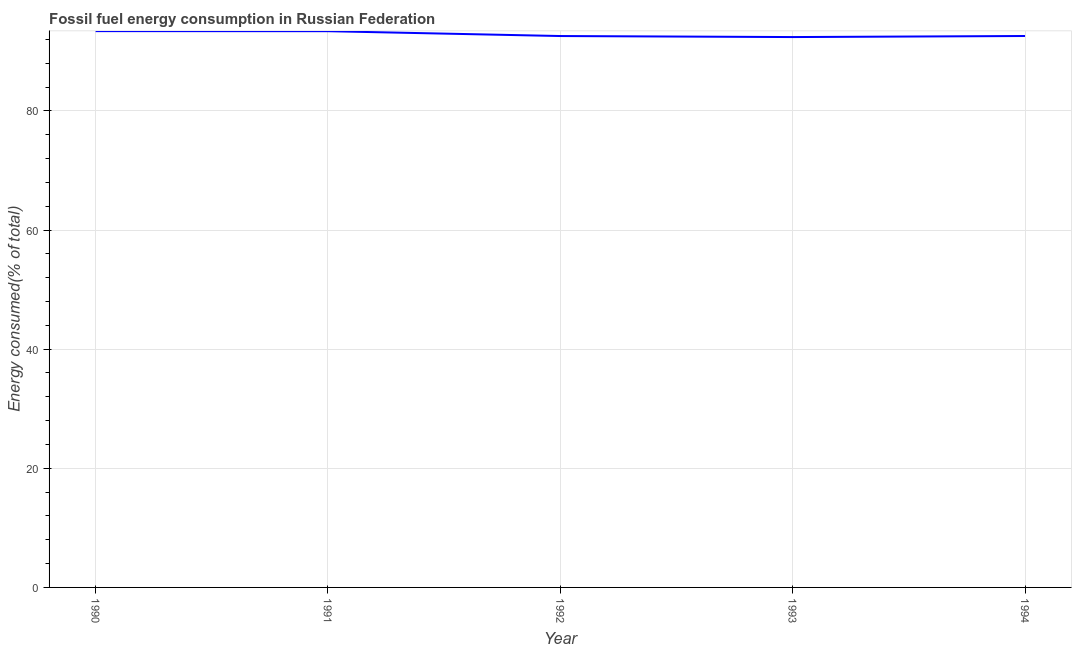What is the fossil fuel energy consumption in 1990?
Make the answer very short. 93.39. Across all years, what is the maximum fossil fuel energy consumption?
Provide a short and direct response. 93.39. Across all years, what is the minimum fossil fuel energy consumption?
Provide a short and direct response. 92.4. In which year was the fossil fuel energy consumption maximum?
Provide a short and direct response. 1990. In which year was the fossil fuel energy consumption minimum?
Offer a very short reply. 1993. What is the sum of the fossil fuel energy consumption?
Offer a very short reply. 464.31. What is the difference between the fossil fuel energy consumption in 1993 and 1994?
Your response must be concise. -0.18. What is the average fossil fuel energy consumption per year?
Your answer should be very brief. 92.86. What is the median fossil fuel energy consumption?
Provide a short and direct response. 92.57. What is the ratio of the fossil fuel energy consumption in 1992 to that in 1993?
Ensure brevity in your answer.  1. Is the fossil fuel energy consumption in 1991 less than that in 1992?
Your answer should be very brief. No. What is the difference between the highest and the second highest fossil fuel energy consumption?
Your answer should be very brief. 0.01. Is the sum of the fossil fuel energy consumption in 1992 and 1994 greater than the maximum fossil fuel energy consumption across all years?
Give a very brief answer. Yes. What is the difference between the highest and the lowest fossil fuel energy consumption?
Your response must be concise. 1. Does the fossil fuel energy consumption monotonically increase over the years?
Provide a short and direct response. No. How many years are there in the graph?
Offer a very short reply. 5. What is the difference between two consecutive major ticks on the Y-axis?
Ensure brevity in your answer.  20. Does the graph contain grids?
Your answer should be very brief. Yes. What is the title of the graph?
Offer a terse response. Fossil fuel energy consumption in Russian Federation. What is the label or title of the X-axis?
Provide a short and direct response. Year. What is the label or title of the Y-axis?
Your answer should be very brief. Energy consumed(% of total). What is the Energy consumed(% of total) in 1990?
Make the answer very short. 93.39. What is the Energy consumed(% of total) in 1991?
Provide a short and direct response. 93.38. What is the Energy consumed(% of total) of 1992?
Offer a terse response. 92.57. What is the Energy consumed(% of total) of 1993?
Your answer should be compact. 92.4. What is the Energy consumed(% of total) of 1994?
Your response must be concise. 92.57. What is the difference between the Energy consumed(% of total) in 1990 and 1991?
Provide a succinct answer. 0.01. What is the difference between the Energy consumed(% of total) in 1990 and 1992?
Make the answer very short. 0.83. What is the difference between the Energy consumed(% of total) in 1990 and 1993?
Your answer should be very brief. 1. What is the difference between the Energy consumed(% of total) in 1990 and 1994?
Provide a succinct answer. 0.82. What is the difference between the Energy consumed(% of total) in 1991 and 1992?
Give a very brief answer. 0.81. What is the difference between the Energy consumed(% of total) in 1991 and 1993?
Offer a very short reply. 0.99. What is the difference between the Energy consumed(% of total) in 1991 and 1994?
Ensure brevity in your answer.  0.81. What is the difference between the Energy consumed(% of total) in 1992 and 1993?
Your answer should be very brief. 0.17. What is the difference between the Energy consumed(% of total) in 1992 and 1994?
Give a very brief answer. -0.01. What is the difference between the Energy consumed(% of total) in 1993 and 1994?
Provide a succinct answer. -0.18. What is the ratio of the Energy consumed(% of total) in 1990 to that in 1993?
Your answer should be very brief. 1.01. What is the ratio of the Energy consumed(% of total) in 1990 to that in 1994?
Ensure brevity in your answer.  1.01. What is the ratio of the Energy consumed(% of total) in 1991 to that in 1993?
Provide a succinct answer. 1.01. What is the ratio of the Energy consumed(% of total) in 1991 to that in 1994?
Provide a succinct answer. 1.01. What is the ratio of the Energy consumed(% of total) in 1992 to that in 1993?
Offer a very short reply. 1. What is the ratio of the Energy consumed(% of total) in 1992 to that in 1994?
Your answer should be very brief. 1. 